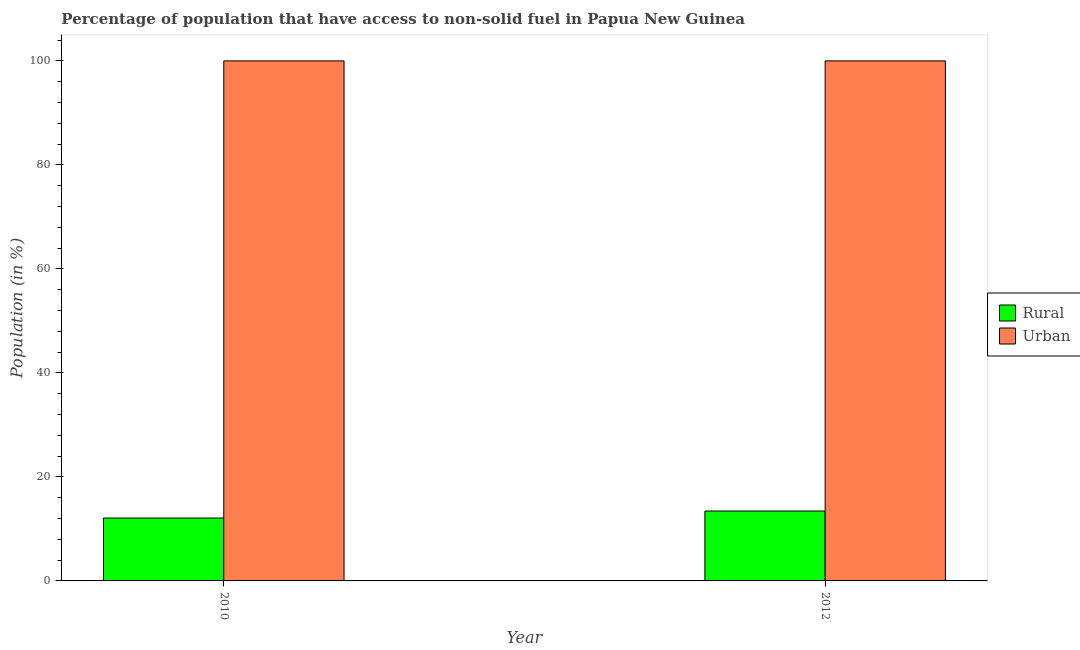How many different coloured bars are there?
Offer a terse response. 2. Are the number of bars per tick equal to the number of legend labels?
Offer a very short reply. Yes. How many bars are there on the 2nd tick from the right?
Ensure brevity in your answer.  2. What is the label of the 1st group of bars from the left?
Offer a terse response. 2010. What is the urban population in 2012?
Offer a terse response. 100. Across all years, what is the maximum rural population?
Make the answer very short. 13.44. Across all years, what is the minimum urban population?
Your response must be concise. 100. In which year was the urban population minimum?
Provide a succinct answer. 2010. What is the total urban population in the graph?
Give a very brief answer. 200. What is the difference between the rural population in 2010 and that in 2012?
Your answer should be very brief. -1.35. What is the difference between the rural population in 2012 and the urban population in 2010?
Give a very brief answer. 1.35. In the year 2012, what is the difference between the urban population and rural population?
Offer a terse response. 0. In how many years, is the rural population greater than 60 %?
Offer a very short reply. 0. What is the ratio of the rural population in 2010 to that in 2012?
Your answer should be compact. 0.9. Is the urban population in 2010 less than that in 2012?
Provide a succinct answer. No. In how many years, is the rural population greater than the average rural population taken over all years?
Provide a short and direct response. 1. What does the 1st bar from the left in 2010 represents?
Ensure brevity in your answer.  Rural. What does the 1st bar from the right in 2012 represents?
Offer a terse response. Urban. How many bars are there?
Offer a terse response. 4. How many years are there in the graph?
Ensure brevity in your answer.  2. Are the values on the major ticks of Y-axis written in scientific E-notation?
Offer a terse response. No. Does the graph contain grids?
Offer a very short reply. No. How are the legend labels stacked?
Provide a short and direct response. Vertical. What is the title of the graph?
Give a very brief answer. Percentage of population that have access to non-solid fuel in Papua New Guinea. What is the Population (in %) of Rural in 2010?
Provide a short and direct response. 12.1. What is the Population (in %) in Rural in 2012?
Your response must be concise. 13.44. Across all years, what is the maximum Population (in %) in Rural?
Your response must be concise. 13.44. Across all years, what is the maximum Population (in %) in Urban?
Keep it short and to the point. 100. Across all years, what is the minimum Population (in %) in Rural?
Your answer should be compact. 12.1. What is the total Population (in %) of Rural in the graph?
Your answer should be compact. 25.54. What is the difference between the Population (in %) in Rural in 2010 and that in 2012?
Ensure brevity in your answer.  -1.35. What is the difference between the Population (in %) in Rural in 2010 and the Population (in %) in Urban in 2012?
Provide a succinct answer. -87.9. What is the average Population (in %) of Rural per year?
Offer a very short reply. 12.77. In the year 2010, what is the difference between the Population (in %) in Rural and Population (in %) in Urban?
Offer a terse response. -87.9. In the year 2012, what is the difference between the Population (in %) of Rural and Population (in %) of Urban?
Give a very brief answer. -86.56. What is the ratio of the Population (in %) of Rural in 2010 to that in 2012?
Offer a very short reply. 0.9. What is the ratio of the Population (in %) in Urban in 2010 to that in 2012?
Offer a terse response. 1. What is the difference between the highest and the second highest Population (in %) of Rural?
Keep it short and to the point. 1.35. What is the difference between the highest and the second highest Population (in %) in Urban?
Give a very brief answer. 0. What is the difference between the highest and the lowest Population (in %) of Rural?
Your answer should be very brief. 1.35. 